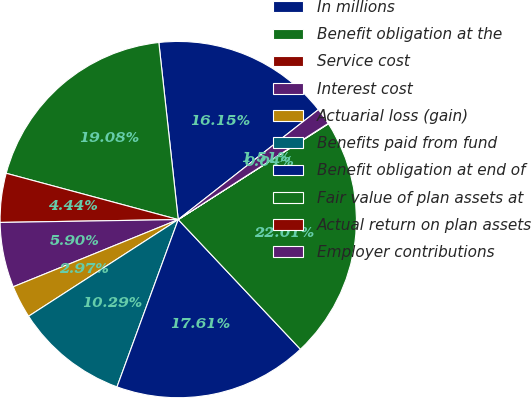Convert chart. <chart><loc_0><loc_0><loc_500><loc_500><pie_chart><fcel>In millions<fcel>Benefit obligation at the<fcel>Service cost<fcel>Interest cost<fcel>Actuarial loss (gain)<fcel>Benefits paid from fund<fcel>Benefit obligation at end of<fcel>Fair value of plan assets at<fcel>Actual return on plan assets<fcel>Employer contributions<nl><fcel>16.15%<fcel>19.08%<fcel>4.44%<fcel>5.9%<fcel>2.97%<fcel>10.29%<fcel>17.61%<fcel>22.01%<fcel>0.04%<fcel>1.51%<nl></chart> 